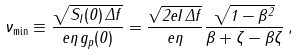<formula> <loc_0><loc_0><loc_500><loc_500>\nu _ { \min } \equiv \frac { \sqrt { S _ { I } ( 0 ) \, \Delta f } } { e \eta \, g _ { p } ( 0 ) } = \frac { \sqrt { 2 e I \, \Delta f } } { e \eta } \frac { \sqrt { 1 - \beta ^ { 2 } } } { \beta + \zeta - \beta \zeta } \, ,</formula> 